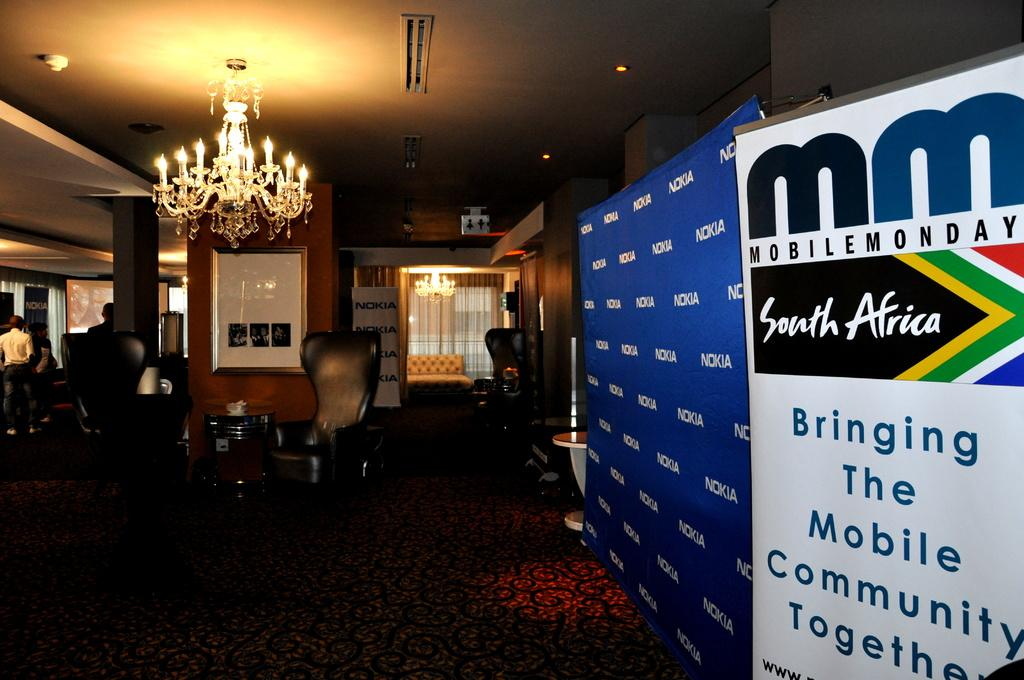<image>
Write a terse but informative summary of the picture. an ad banner for mobile monday looks like its part of an event 